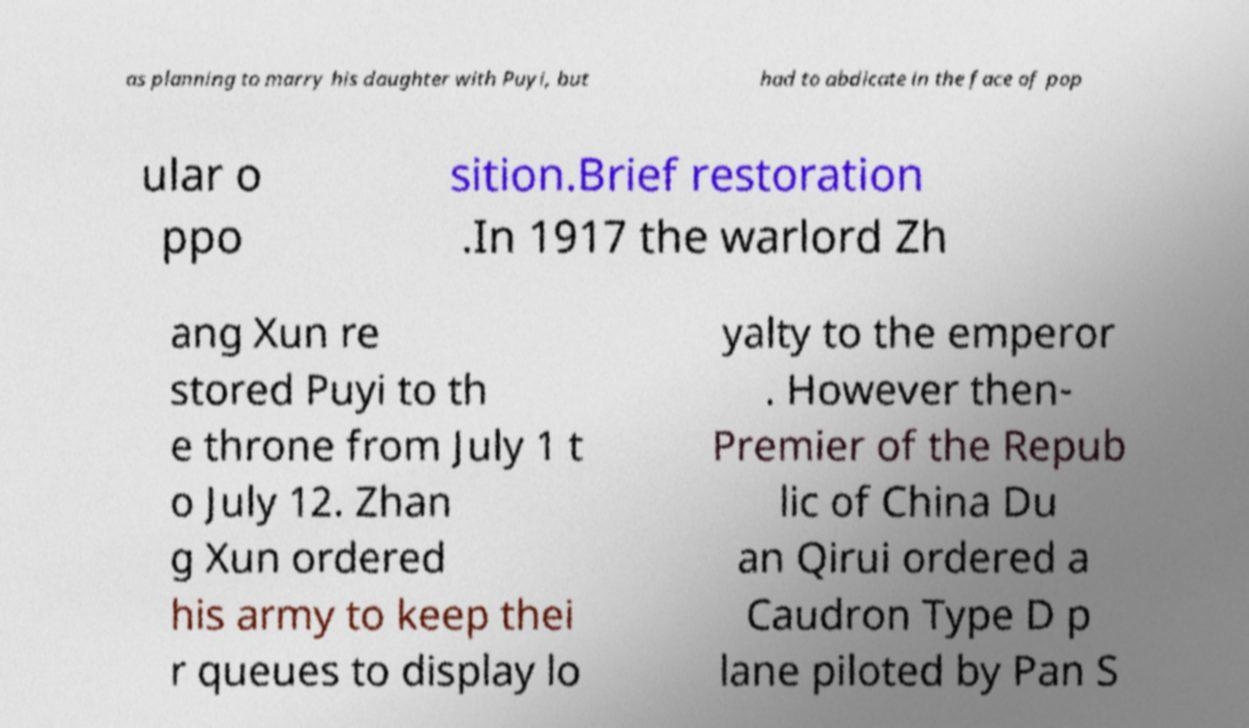Please read and relay the text visible in this image. What does it say? as planning to marry his daughter with Puyi, but had to abdicate in the face of pop ular o ppo sition.Brief restoration .In 1917 the warlord Zh ang Xun re stored Puyi to th e throne from July 1 t o July 12. Zhan g Xun ordered his army to keep thei r queues to display lo yalty to the emperor . However then- Premier of the Repub lic of China Du an Qirui ordered a Caudron Type D p lane piloted by Pan S 